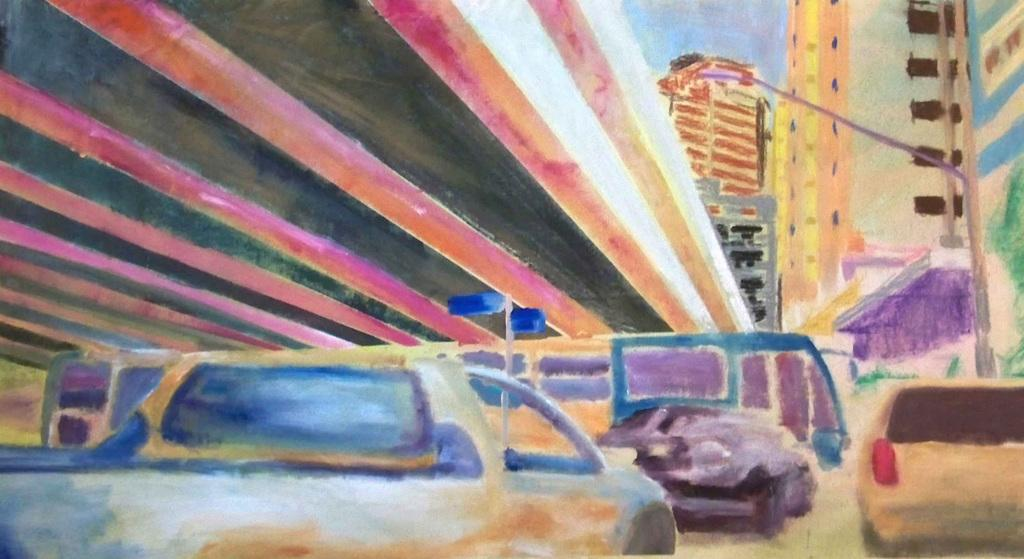What type of objects are depicted in the drawing in the image? The drawing in the image contains vehicles and buildings. What else is included in the drawing? The drawing also contains a depiction of the sky. What type of jewel can be seen in the drawing in the image? There is no jewel present in the drawing in the image; it contains vehicles, buildings, and the sky. 